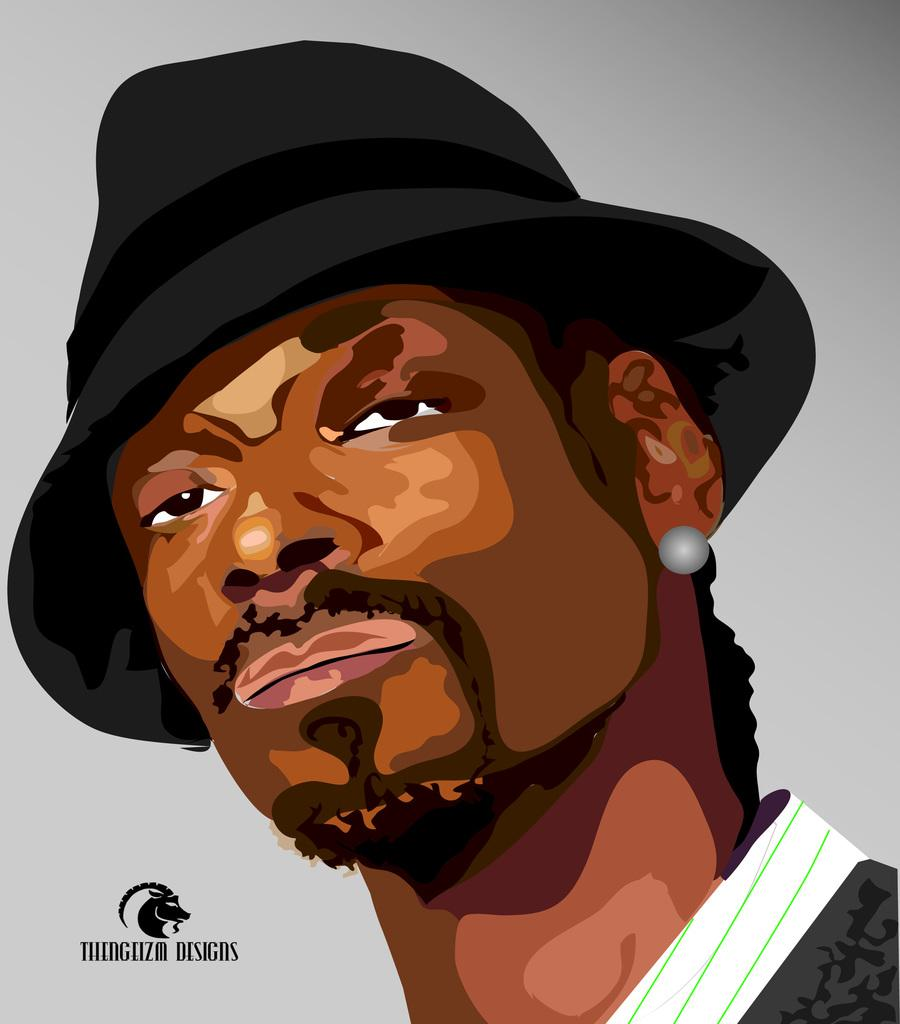What is the main subject of the image? There is a painting in the image. What is depicted in the painting? The painting depicts a person. Can you describe the person's attire in the painting? The person in the painting is wearing a cap. Where did the person in the painting go on vacation? There is no information about the person in the painting going on vacation, as the image only shows a painting of a person wearing a cap. 